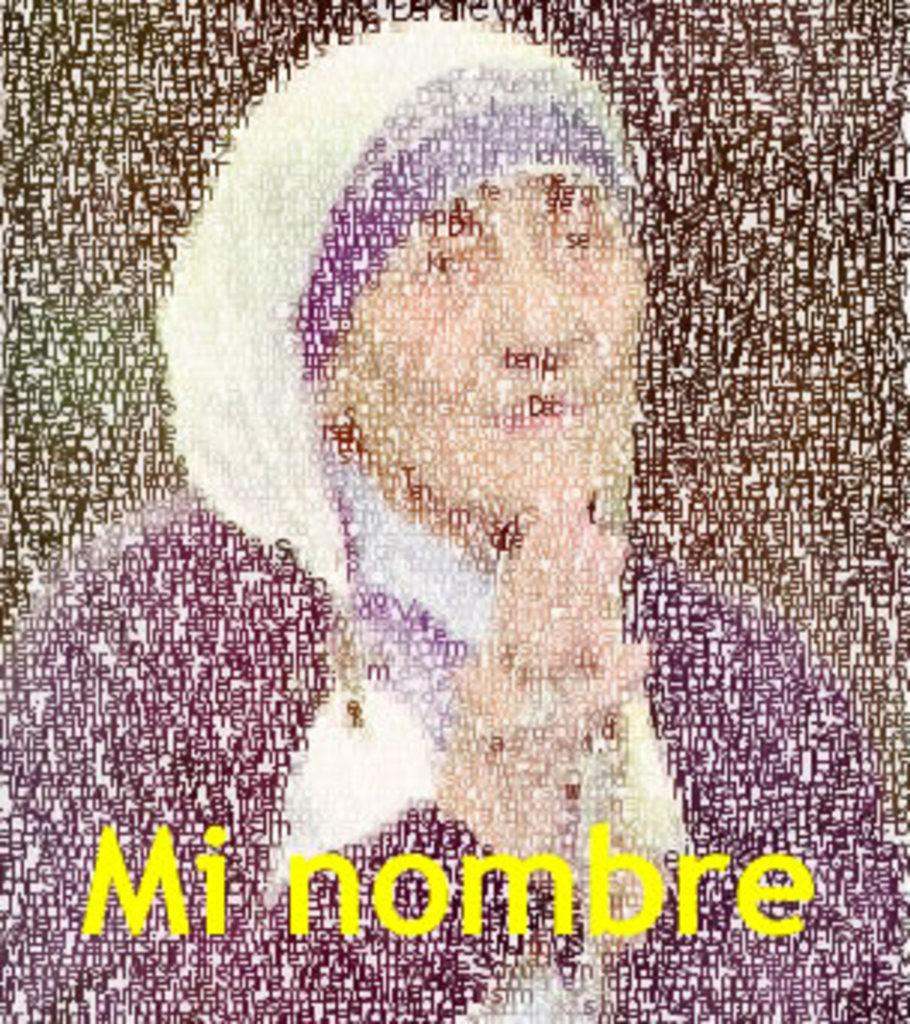Who is present in the image? There is a woman in the image. What can be found at the bottom of the image? There is text written at the bottom of the image. Reasoning: Let' Let's think step by step in order to produce the conversation. We start by identifying the main subject in the image, which is the woman. Then, we focus on the other important detail mentioned in the facts, which is the text at the bottom of the image. We formulate questions that address these specific details, ensuring that each question can be answered definitively with the information given. We avoid yes/no questions and ensure that the language is simple and clear. Absurd Question/Answer: Can you see a frog hopping in the image? There is no frog present in the image. What color is the thread used to write the text at the bottom of the image? The facts do not mention any thread or the color of the text, so we cannot determine the color of the thread used to write the text. How many frogs are visible in the image? There are no frogs present in the image. What type of thread is used to write the text at the bottom of the image? The facts do not mention any thread or the color of the text, so we cannot determine the type of thread used to write the text. 